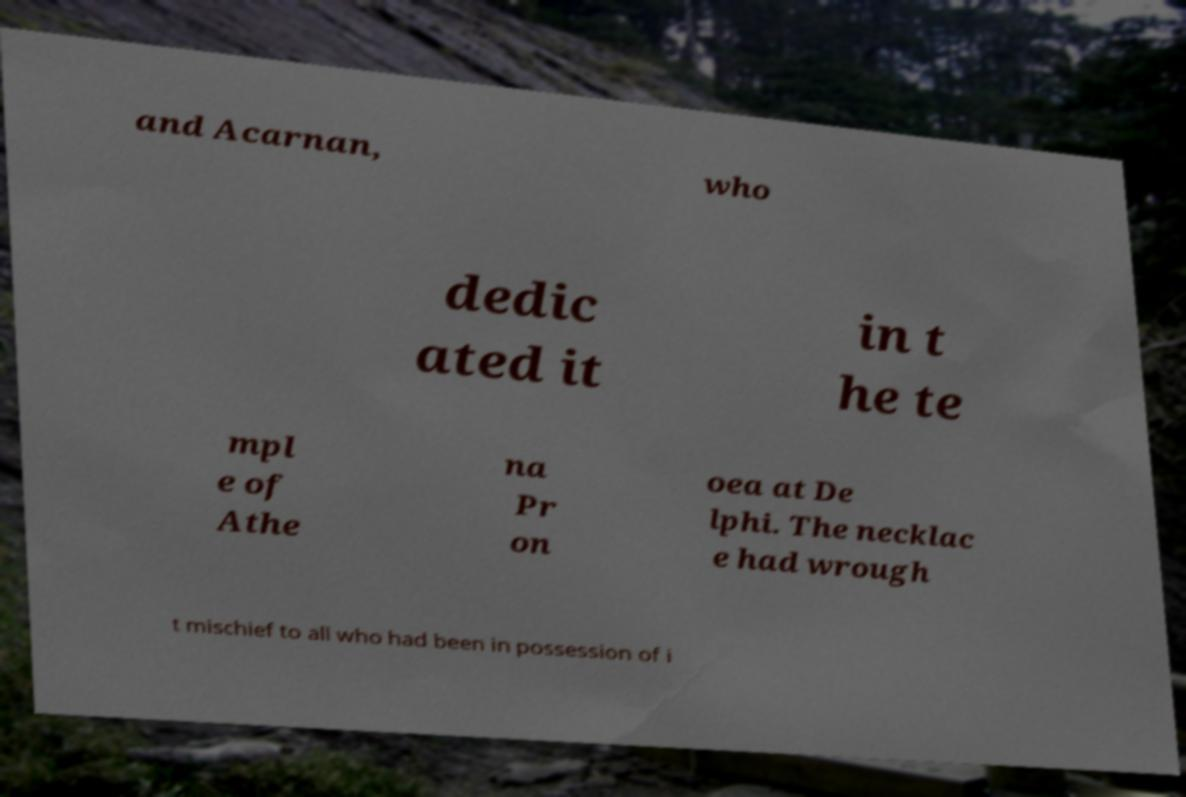I need the written content from this picture converted into text. Can you do that? and Acarnan, who dedic ated it in t he te mpl e of Athe na Pr on oea at De lphi. The necklac e had wrough t mischief to all who had been in possession of i 